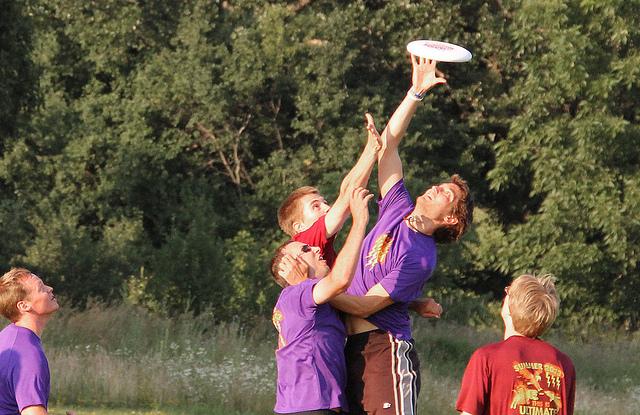Why are the men jumping?
Be succinct. To catch frisbee. Is this a team competition?
Keep it brief. Yes. What is being caught?
Quick response, please. Frisbee. 